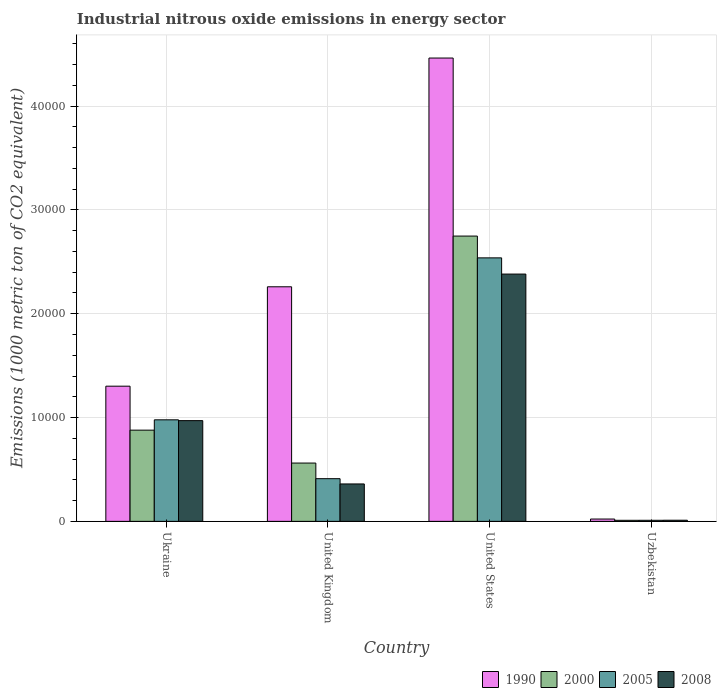How many groups of bars are there?
Provide a succinct answer. 4. Are the number of bars on each tick of the X-axis equal?
Offer a very short reply. Yes. How many bars are there on the 2nd tick from the left?
Make the answer very short. 4. How many bars are there on the 2nd tick from the right?
Offer a terse response. 4. What is the label of the 2nd group of bars from the left?
Your response must be concise. United Kingdom. In how many cases, is the number of bars for a given country not equal to the number of legend labels?
Your response must be concise. 0. What is the amount of industrial nitrous oxide emitted in 2005 in United Kingdom?
Your response must be concise. 4111.2. Across all countries, what is the maximum amount of industrial nitrous oxide emitted in 2005?
Give a very brief answer. 2.54e+04. Across all countries, what is the minimum amount of industrial nitrous oxide emitted in 2000?
Offer a very short reply. 101.6. In which country was the amount of industrial nitrous oxide emitted in 1990 minimum?
Your answer should be compact. Uzbekistan. What is the total amount of industrial nitrous oxide emitted in 2000 in the graph?
Offer a very short reply. 4.20e+04. What is the difference between the amount of industrial nitrous oxide emitted in 1990 in United Kingdom and that in United States?
Your answer should be very brief. -2.20e+04. What is the difference between the amount of industrial nitrous oxide emitted in 2008 in United States and the amount of industrial nitrous oxide emitted in 1990 in United Kingdom?
Offer a very short reply. 1224.8. What is the average amount of industrial nitrous oxide emitted in 2008 per country?
Provide a succinct answer. 9308.4. What is the difference between the amount of industrial nitrous oxide emitted of/in 1990 and amount of industrial nitrous oxide emitted of/in 2000 in United States?
Your response must be concise. 1.71e+04. In how many countries, is the amount of industrial nitrous oxide emitted in 1990 greater than 12000 1000 metric ton?
Your answer should be compact. 3. What is the ratio of the amount of industrial nitrous oxide emitted in 2000 in United Kingdom to that in United States?
Give a very brief answer. 0.2. Is the difference between the amount of industrial nitrous oxide emitted in 1990 in United States and Uzbekistan greater than the difference between the amount of industrial nitrous oxide emitted in 2000 in United States and Uzbekistan?
Provide a succinct answer. Yes. What is the difference between the highest and the second highest amount of industrial nitrous oxide emitted in 2008?
Ensure brevity in your answer.  2.02e+04. What is the difference between the highest and the lowest amount of industrial nitrous oxide emitted in 2005?
Make the answer very short. 2.53e+04. In how many countries, is the amount of industrial nitrous oxide emitted in 1990 greater than the average amount of industrial nitrous oxide emitted in 1990 taken over all countries?
Offer a very short reply. 2. Is it the case that in every country, the sum of the amount of industrial nitrous oxide emitted in 2005 and amount of industrial nitrous oxide emitted in 2008 is greater than the sum of amount of industrial nitrous oxide emitted in 1990 and amount of industrial nitrous oxide emitted in 2000?
Ensure brevity in your answer.  No. What does the 2nd bar from the left in Uzbekistan represents?
Give a very brief answer. 2000. What does the 2nd bar from the right in Ukraine represents?
Ensure brevity in your answer.  2005. How many bars are there?
Your response must be concise. 16. Are all the bars in the graph horizontal?
Ensure brevity in your answer.  No. How many countries are there in the graph?
Offer a very short reply. 4. Where does the legend appear in the graph?
Your answer should be compact. Bottom right. How are the legend labels stacked?
Make the answer very short. Horizontal. What is the title of the graph?
Provide a short and direct response. Industrial nitrous oxide emissions in energy sector. Does "1976" appear as one of the legend labels in the graph?
Offer a terse response. No. What is the label or title of the Y-axis?
Ensure brevity in your answer.  Emissions (1000 metric ton of CO2 equivalent). What is the Emissions (1000 metric ton of CO2 equivalent) in 1990 in Ukraine?
Your response must be concise. 1.30e+04. What is the Emissions (1000 metric ton of CO2 equivalent) of 2000 in Ukraine?
Your answer should be compact. 8784.8. What is the Emissions (1000 metric ton of CO2 equivalent) of 2005 in Ukraine?
Your answer should be very brief. 9779.9. What is the Emissions (1000 metric ton of CO2 equivalent) in 2008 in Ukraine?
Your answer should be very brief. 9701.8. What is the Emissions (1000 metric ton of CO2 equivalent) in 1990 in United Kingdom?
Your response must be concise. 2.26e+04. What is the Emissions (1000 metric ton of CO2 equivalent) in 2000 in United Kingdom?
Offer a very short reply. 5616. What is the Emissions (1000 metric ton of CO2 equivalent) of 2005 in United Kingdom?
Make the answer very short. 4111.2. What is the Emissions (1000 metric ton of CO2 equivalent) in 2008 in United Kingdom?
Your answer should be very brief. 3604.6. What is the Emissions (1000 metric ton of CO2 equivalent) in 1990 in United States?
Give a very brief answer. 4.46e+04. What is the Emissions (1000 metric ton of CO2 equivalent) of 2000 in United States?
Your response must be concise. 2.75e+04. What is the Emissions (1000 metric ton of CO2 equivalent) of 2005 in United States?
Your answer should be very brief. 2.54e+04. What is the Emissions (1000 metric ton of CO2 equivalent) of 2008 in United States?
Your response must be concise. 2.38e+04. What is the Emissions (1000 metric ton of CO2 equivalent) in 1990 in Uzbekistan?
Your answer should be compact. 223.2. What is the Emissions (1000 metric ton of CO2 equivalent) in 2000 in Uzbekistan?
Give a very brief answer. 101.6. What is the Emissions (1000 metric ton of CO2 equivalent) of 2005 in Uzbekistan?
Offer a very short reply. 103.2. What is the Emissions (1000 metric ton of CO2 equivalent) of 2008 in Uzbekistan?
Your answer should be very brief. 109.4. Across all countries, what is the maximum Emissions (1000 metric ton of CO2 equivalent) in 1990?
Your answer should be very brief. 4.46e+04. Across all countries, what is the maximum Emissions (1000 metric ton of CO2 equivalent) in 2000?
Offer a very short reply. 2.75e+04. Across all countries, what is the maximum Emissions (1000 metric ton of CO2 equivalent) in 2005?
Your answer should be compact. 2.54e+04. Across all countries, what is the maximum Emissions (1000 metric ton of CO2 equivalent) of 2008?
Ensure brevity in your answer.  2.38e+04. Across all countries, what is the minimum Emissions (1000 metric ton of CO2 equivalent) of 1990?
Offer a terse response. 223.2. Across all countries, what is the minimum Emissions (1000 metric ton of CO2 equivalent) of 2000?
Give a very brief answer. 101.6. Across all countries, what is the minimum Emissions (1000 metric ton of CO2 equivalent) in 2005?
Offer a terse response. 103.2. Across all countries, what is the minimum Emissions (1000 metric ton of CO2 equivalent) in 2008?
Your response must be concise. 109.4. What is the total Emissions (1000 metric ton of CO2 equivalent) of 1990 in the graph?
Give a very brief answer. 8.05e+04. What is the total Emissions (1000 metric ton of CO2 equivalent) in 2000 in the graph?
Offer a very short reply. 4.20e+04. What is the total Emissions (1000 metric ton of CO2 equivalent) of 2005 in the graph?
Offer a terse response. 3.94e+04. What is the total Emissions (1000 metric ton of CO2 equivalent) of 2008 in the graph?
Keep it short and to the point. 3.72e+04. What is the difference between the Emissions (1000 metric ton of CO2 equivalent) in 1990 in Ukraine and that in United Kingdom?
Keep it short and to the point. -9573. What is the difference between the Emissions (1000 metric ton of CO2 equivalent) in 2000 in Ukraine and that in United Kingdom?
Ensure brevity in your answer.  3168.8. What is the difference between the Emissions (1000 metric ton of CO2 equivalent) in 2005 in Ukraine and that in United Kingdom?
Your answer should be compact. 5668.7. What is the difference between the Emissions (1000 metric ton of CO2 equivalent) in 2008 in Ukraine and that in United Kingdom?
Make the answer very short. 6097.2. What is the difference between the Emissions (1000 metric ton of CO2 equivalent) in 1990 in Ukraine and that in United States?
Make the answer very short. -3.16e+04. What is the difference between the Emissions (1000 metric ton of CO2 equivalent) of 2000 in Ukraine and that in United States?
Ensure brevity in your answer.  -1.87e+04. What is the difference between the Emissions (1000 metric ton of CO2 equivalent) of 2005 in Ukraine and that in United States?
Offer a terse response. -1.56e+04. What is the difference between the Emissions (1000 metric ton of CO2 equivalent) of 2008 in Ukraine and that in United States?
Make the answer very short. -1.41e+04. What is the difference between the Emissions (1000 metric ton of CO2 equivalent) in 1990 in Ukraine and that in Uzbekistan?
Offer a very short reply. 1.28e+04. What is the difference between the Emissions (1000 metric ton of CO2 equivalent) of 2000 in Ukraine and that in Uzbekistan?
Ensure brevity in your answer.  8683.2. What is the difference between the Emissions (1000 metric ton of CO2 equivalent) in 2005 in Ukraine and that in Uzbekistan?
Make the answer very short. 9676.7. What is the difference between the Emissions (1000 metric ton of CO2 equivalent) of 2008 in Ukraine and that in Uzbekistan?
Your response must be concise. 9592.4. What is the difference between the Emissions (1000 metric ton of CO2 equivalent) of 1990 in United Kingdom and that in United States?
Ensure brevity in your answer.  -2.20e+04. What is the difference between the Emissions (1000 metric ton of CO2 equivalent) of 2000 in United Kingdom and that in United States?
Provide a succinct answer. -2.19e+04. What is the difference between the Emissions (1000 metric ton of CO2 equivalent) of 2005 in United Kingdom and that in United States?
Your answer should be compact. -2.13e+04. What is the difference between the Emissions (1000 metric ton of CO2 equivalent) in 2008 in United Kingdom and that in United States?
Provide a succinct answer. -2.02e+04. What is the difference between the Emissions (1000 metric ton of CO2 equivalent) in 1990 in United Kingdom and that in Uzbekistan?
Make the answer very short. 2.24e+04. What is the difference between the Emissions (1000 metric ton of CO2 equivalent) in 2000 in United Kingdom and that in Uzbekistan?
Give a very brief answer. 5514.4. What is the difference between the Emissions (1000 metric ton of CO2 equivalent) of 2005 in United Kingdom and that in Uzbekistan?
Your response must be concise. 4008. What is the difference between the Emissions (1000 metric ton of CO2 equivalent) of 2008 in United Kingdom and that in Uzbekistan?
Offer a terse response. 3495.2. What is the difference between the Emissions (1000 metric ton of CO2 equivalent) in 1990 in United States and that in Uzbekistan?
Keep it short and to the point. 4.44e+04. What is the difference between the Emissions (1000 metric ton of CO2 equivalent) of 2000 in United States and that in Uzbekistan?
Your answer should be very brief. 2.74e+04. What is the difference between the Emissions (1000 metric ton of CO2 equivalent) of 2005 in United States and that in Uzbekistan?
Your response must be concise. 2.53e+04. What is the difference between the Emissions (1000 metric ton of CO2 equivalent) in 2008 in United States and that in Uzbekistan?
Keep it short and to the point. 2.37e+04. What is the difference between the Emissions (1000 metric ton of CO2 equivalent) of 1990 in Ukraine and the Emissions (1000 metric ton of CO2 equivalent) of 2000 in United Kingdom?
Make the answer very short. 7404. What is the difference between the Emissions (1000 metric ton of CO2 equivalent) in 1990 in Ukraine and the Emissions (1000 metric ton of CO2 equivalent) in 2005 in United Kingdom?
Your response must be concise. 8908.8. What is the difference between the Emissions (1000 metric ton of CO2 equivalent) in 1990 in Ukraine and the Emissions (1000 metric ton of CO2 equivalent) in 2008 in United Kingdom?
Keep it short and to the point. 9415.4. What is the difference between the Emissions (1000 metric ton of CO2 equivalent) in 2000 in Ukraine and the Emissions (1000 metric ton of CO2 equivalent) in 2005 in United Kingdom?
Offer a very short reply. 4673.6. What is the difference between the Emissions (1000 metric ton of CO2 equivalent) in 2000 in Ukraine and the Emissions (1000 metric ton of CO2 equivalent) in 2008 in United Kingdom?
Provide a short and direct response. 5180.2. What is the difference between the Emissions (1000 metric ton of CO2 equivalent) in 2005 in Ukraine and the Emissions (1000 metric ton of CO2 equivalent) in 2008 in United Kingdom?
Give a very brief answer. 6175.3. What is the difference between the Emissions (1000 metric ton of CO2 equivalent) in 1990 in Ukraine and the Emissions (1000 metric ton of CO2 equivalent) in 2000 in United States?
Give a very brief answer. -1.45e+04. What is the difference between the Emissions (1000 metric ton of CO2 equivalent) in 1990 in Ukraine and the Emissions (1000 metric ton of CO2 equivalent) in 2005 in United States?
Provide a succinct answer. -1.24e+04. What is the difference between the Emissions (1000 metric ton of CO2 equivalent) of 1990 in Ukraine and the Emissions (1000 metric ton of CO2 equivalent) of 2008 in United States?
Make the answer very short. -1.08e+04. What is the difference between the Emissions (1000 metric ton of CO2 equivalent) of 2000 in Ukraine and the Emissions (1000 metric ton of CO2 equivalent) of 2005 in United States?
Offer a very short reply. -1.66e+04. What is the difference between the Emissions (1000 metric ton of CO2 equivalent) of 2000 in Ukraine and the Emissions (1000 metric ton of CO2 equivalent) of 2008 in United States?
Your response must be concise. -1.50e+04. What is the difference between the Emissions (1000 metric ton of CO2 equivalent) in 2005 in Ukraine and the Emissions (1000 metric ton of CO2 equivalent) in 2008 in United States?
Provide a succinct answer. -1.40e+04. What is the difference between the Emissions (1000 metric ton of CO2 equivalent) of 1990 in Ukraine and the Emissions (1000 metric ton of CO2 equivalent) of 2000 in Uzbekistan?
Provide a short and direct response. 1.29e+04. What is the difference between the Emissions (1000 metric ton of CO2 equivalent) of 1990 in Ukraine and the Emissions (1000 metric ton of CO2 equivalent) of 2005 in Uzbekistan?
Your answer should be compact. 1.29e+04. What is the difference between the Emissions (1000 metric ton of CO2 equivalent) in 1990 in Ukraine and the Emissions (1000 metric ton of CO2 equivalent) in 2008 in Uzbekistan?
Your answer should be very brief. 1.29e+04. What is the difference between the Emissions (1000 metric ton of CO2 equivalent) in 2000 in Ukraine and the Emissions (1000 metric ton of CO2 equivalent) in 2005 in Uzbekistan?
Your answer should be compact. 8681.6. What is the difference between the Emissions (1000 metric ton of CO2 equivalent) of 2000 in Ukraine and the Emissions (1000 metric ton of CO2 equivalent) of 2008 in Uzbekistan?
Your answer should be very brief. 8675.4. What is the difference between the Emissions (1000 metric ton of CO2 equivalent) of 2005 in Ukraine and the Emissions (1000 metric ton of CO2 equivalent) of 2008 in Uzbekistan?
Provide a succinct answer. 9670.5. What is the difference between the Emissions (1000 metric ton of CO2 equivalent) in 1990 in United Kingdom and the Emissions (1000 metric ton of CO2 equivalent) in 2000 in United States?
Your answer should be very brief. -4884.9. What is the difference between the Emissions (1000 metric ton of CO2 equivalent) of 1990 in United Kingdom and the Emissions (1000 metric ton of CO2 equivalent) of 2005 in United States?
Make the answer very short. -2785.7. What is the difference between the Emissions (1000 metric ton of CO2 equivalent) in 1990 in United Kingdom and the Emissions (1000 metric ton of CO2 equivalent) in 2008 in United States?
Your answer should be compact. -1224.8. What is the difference between the Emissions (1000 metric ton of CO2 equivalent) in 2000 in United Kingdom and the Emissions (1000 metric ton of CO2 equivalent) in 2005 in United States?
Offer a very short reply. -1.98e+04. What is the difference between the Emissions (1000 metric ton of CO2 equivalent) in 2000 in United Kingdom and the Emissions (1000 metric ton of CO2 equivalent) in 2008 in United States?
Offer a terse response. -1.82e+04. What is the difference between the Emissions (1000 metric ton of CO2 equivalent) in 2005 in United Kingdom and the Emissions (1000 metric ton of CO2 equivalent) in 2008 in United States?
Your answer should be compact. -1.97e+04. What is the difference between the Emissions (1000 metric ton of CO2 equivalent) in 1990 in United Kingdom and the Emissions (1000 metric ton of CO2 equivalent) in 2000 in Uzbekistan?
Provide a succinct answer. 2.25e+04. What is the difference between the Emissions (1000 metric ton of CO2 equivalent) in 1990 in United Kingdom and the Emissions (1000 metric ton of CO2 equivalent) in 2005 in Uzbekistan?
Ensure brevity in your answer.  2.25e+04. What is the difference between the Emissions (1000 metric ton of CO2 equivalent) in 1990 in United Kingdom and the Emissions (1000 metric ton of CO2 equivalent) in 2008 in Uzbekistan?
Offer a very short reply. 2.25e+04. What is the difference between the Emissions (1000 metric ton of CO2 equivalent) in 2000 in United Kingdom and the Emissions (1000 metric ton of CO2 equivalent) in 2005 in Uzbekistan?
Your answer should be compact. 5512.8. What is the difference between the Emissions (1000 metric ton of CO2 equivalent) in 2000 in United Kingdom and the Emissions (1000 metric ton of CO2 equivalent) in 2008 in Uzbekistan?
Keep it short and to the point. 5506.6. What is the difference between the Emissions (1000 metric ton of CO2 equivalent) of 2005 in United Kingdom and the Emissions (1000 metric ton of CO2 equivalent) of 2008 in Uzbekistan?
Provide a short and direct response. 4001.8. What is the difference between the Emissions (1000 metric ton of CO2 equivalent) of 1990 in United States and the Emissions (1000 metric ton of CO2 equivalent) of 2000 in Uzbekistan?
Offer a very short reply. 4.45e+04. What is the difference between the Emissions (1000 metric ton of CO2 equivalent) of 1990 in United States and the Emissions (1000 metric ton of CO2 equivalent) of 2005 in Uzbekistan?
Offer a terse response. 4.45e+04. What is the difference between the Emissions (1000 metric ton of CO2 equivalent) in 1990 in United States and the Emissions (1000 metric ton of CO2 equivalent) in 2008 in Uzbekistan?
Provide a short and direct response. 4.45e+04. What is the difference between the Emissions (1000 metric ton of CO2 equivalent) in 2000 in United States and the Emissions (1000 metric ton of CO2 equivalent) in 2005 in Uzbekistan?
Your answer should be very brief. 2.74e+04. What is the difference between the Emissions (1000 metric ton of CO2 equivalent) in 2000 in United States and the Emissions (1000 metric ton of CO2 equivalent) in 2008 in Uzbekistan?
Keep it short and to the point. 2.74e+04. What is the difference between the Emissions (1000 metric ton of CO2 equivalent) in 2005 in United States and the Emissions (1000 metric ton of CO2 equivalent) in 2008 in Uzbekistan?
Keep it short and to the point. 2.53e+04. What is the average Emissions (1000 metric ton of CO2 equivalent) in 1990 per country?
Keep it short and to the point. 2.01e+04. What is the average Emissions (1000 metric ton of CO2 equivalent) in 2000 per country?
Ensure brevity in your answer.  1.05e+04. What is the average Emissions (1000 metric ton of CO2 equivalent) of 2005 per country?
Offer a very short reply. 9843.25. What is the average Emissions (1000 metric ton of CO2 equivalent) in 2008 per country?
Offer a very short reply. 9308.4. What is the difference between the Emissions (1000 metric ton of CO2 equivalent) in 1990 and Emissions (1000 metric ton of CO2 equivalent) in 2000 in Ukraine?
Your response must be concise. 4235.2. What is the difference between the Emissions (1000 metric ton of CO2 equivalent) in 1990 and Emissions (1000 metric ton of CO2 equivalent) in 2005 in Ukraine?
Offer a very short reply. 3240.1. What is the difference between the Emissions (1000 metric ton of CO2 equivalent) of 1990 and Emissions (1000 metric ton of CO2 equivalent) of 2008 in Ukraine?
Offer a very short reply. 3318.2. What is the difference between the Emissions (1000 metric ton of CO2 equivalent) in 2000 and Emissions (1000 metric ton of CO2 equivalent) in 2005 in Ukraine?
Give a very brief answer. -995.1. What is the difference between the Emissions (1000 metric ton of CO2 equivalent) of 2000 and Emissions (1000 metric ton of CO2 equivalent) of 2008 in Ukraine?
Keep it short and to the point. -917. What is the difference between the Emissions (1000 metric ton of CO2 equivalent) in 2005 and Emissions (1000 metric ton of CO2 equivalent) in 2008 in Ukraine?
Offer a terse response. 78.1. What is the difference between the Emissions (1000 metric ton of CO2 equivalent) of 1990 and Emissions (1000 metric ton of CO2 equivalent) of 2000 in United Kingdom?
Your answer should be compact. 1.70e+04. What is the difference between the Emissions (1000 metric ton of CO2 equivalent) in 1990 and Emissions (1000 metric ton of CO2 equivalent) in 2005 in United Kingdom?
Provide a succinct answer. 1.85e+04. What is the difference between the Emissions (1000 metric ton of CO2 equivalent) of 1990 and Emissions (1000 metric ton of CO2 equivalent) of 2008 in United Kingdom?
Your response must be concise. 1.90e+04. What is the difference between the Emissions (1000 metric ton of CO2 equivalent) of 2000 and Emissions (1000 metric ton of CO2 equivalent) of 2005 in United Kingdom?
Give a very brief answer. 1504.8. What is the difference between the Emissions (1000 metric ton of CO2 equivalent) of 2000 and Emissions (1000 metric ton of CO2 equivalent) of 2008 in United Kingdom?
Ensure brevity in your answer.  2011.4. What is the difference between the Emissions (1000 metric ton of CO2 equivalent) in 2005 and Emissions (1000 metric ton of CO2 equivalent) in 2008 in United Kingdom?
Give a very brief answer. 506.6. What is the difference between the Emissions (1000 metric ton of CO2 equivalent) in 1990 and Emissions (1000 metric ton of CO2 equivalent) in 2000 in United States?
Provide a short and direct response. 1.71e+04. What is the difference between the Emissions (1000 metric ton of CO2 equivalent) in 1990 and Emissions (1000 metric ton of CO2 equivalent) in 2005 in United States?
Provide a succinct answer. 1.92e+04. What is the difference between the Emissions (1000 metric ton of CO2 equivalent) in 1990 and Emissions (1000 metric ton of CO2 equivalent) in 2008 in United States?
Ensure brevity in your answer.  2.08e+04. What is the difference between the Emissions (1000 metric ton of CO2 equivalent) of 2000 and Emissions (1000 metric ton of CO2 equivalent) of 2005 in United States?
Your answer should be very brief. 2099.2. What is the difference between the Emissions (1000 metric ton of CO2 equivalent) in 2000 and Emissions (1000 metric ton of CO2 equivalent) in 2008 in United States?
Offer a terse response. 3660.1. What is the difference between the Emissions (1000 metric ton of CO2 equivalent) of 2005 and Emissions (1000 metric ton of CO2 equivalent) of 2008 in United States?
Provide a succinct answer. 1560.9. What is the difference between the Emissions (1000 metric ton of CO2 equivalent) in 1990 and Emissions (1000 metric ton of CO2 equivalent) in 2000 in Uzbekistan?
Offer a very short reply. 121.6. What is the difference between the Emissions (1000 metric ton of CO2 equivalent) in 1990 and Emissions (1000 metric ton of CO2 equivalent) in 2005 in Uzbekistan?
Your answer should be very brief. 120. What is the difference between the Emissions (1000 metric ton of CO2 equivalent) of 1990 and Emissions (1000 metric ton of CO2 equivalent) of 2008 in Uzbekistan?
Offer a very short reply. 113.8. What is the difference between the Emissions (1000 metric ton of CO2 equivalent) in 2000 and Emissions (1000 metric ton of CO2 equivalent) in 2005 in Uzbekistan?
Ensure brevity in your answer.  -1.6. What is the difference between the Emissions (1000 metric ton of CO2 equivalent) in 2005 and Emissions (1000 metric ton of CO2 equivalent) in 2008 in Uzbekistan?
Provide a succinct answer. -6.2. What is the ratio of the Emissions (1000 metric ton of CO2 equivalent) in 1990 in Ukraine to that in United Kingdom?
Offer a very short reply. 0.58. What is the ratio of the Emissions (1000 metric ton of CO2 equivalent) of 2000 in Ukraine to that in United Kingdom?
Offer a very short reply. 1.56. What is the ratio of the Emissions (1000 metric ton of CO2 equivalent) of 2005 in Ukraine to that in United Kingdom?
Offer a terse response. 2.38. What is the ratio of the Emissions (1000 metric ton of CO2 equivalent) of 2008 in Ukraine to that in United Kingdom?
Offer a terse response. 2.69. What is the ratio of the Emissions (1000 metric ton of CO2 equivalent) in 1990 in Ukraine to that in United States?
Your answer should be very brief. 0.29. What is the ratio of the Emissions (1000 metric ton of CO2 equivalent) of 2000 in Ukraine to that in United States?
Offer a very short reply. 0.32. What is the ratio of the Emissions (1000 metric ton of CO2 equivalent) in 2005 in Ukraine to that in United States?
Offer a very short reply. 0.39. What is the ratio of the Emissions (1000 metric ton of CO2 equivalent) of 2008 in Ukraine to that in United States?
Give a very brief answer. 0.41. What is the ratio of the Emissions (1000 metric ton of CO2 equivalent) in 1990 in Ukraine to that in Uzbekistan?
Your response must be concise. 58.33. What is the ratio of the Emissions (1000 metric ton of CO2 equivalent) in 2000 in Ukraine to that in Uzbekistan?
Your response must be concise. 86.46. What is the ratio of the Emissions (1000 metric ton of CO2 equivalent) of 2005 in Ukraine to that in Uzbekistan?
Make the answer very short. 94.77. What is the ratio of the Emissions (1000 metric ton of CO2 equivalent) in 2008 in Ukraine to that in Uzbekistan?
Provide a succinct answer. 88.68. What is the ratio of the Emissions (1000 metric ton of CO2 equivalent) in 1990 in United Kingdom to that in United States?
Provide a succinct answer. 0.51. What is the ratio of the Emissions (1000 metric ton of CO2 equivalent) in 2000 in United Kingdom to that in United States?
Offer a terse response. 0.2. What is the ratio of the Emissions (1000 metric ton of CO2 equivalent) of 2005 in United Kingdom to that in United States?
Ensure brevity in your answer.  0.16. What is the ratio of the Emissions (1000 metric ton of CO2 equivalent) in 2008 in United Kingdom to that in United States?
Your answer should be compact. 0.15. What is the ratio of the Emissions (1000 metric ton of CO2 equivalent) in 1990 in United Kingdom to that in Uzbekistan?
Give a very brief answer. 101.22. What is the ratio of the Emissions (1000 metric ton of CO2 equivalent) of 2000 in United Kingdom to that in Uzbekistan?
Provide a short and direct response. 55.28. What is the ratio of the Emissions (1000 metric ton of CO2 equivalent) in 2005 in United Kingdom to that in Uzbekistan?
Ensure brevity in your answer.  39.84. What is the ratio of the Emissions (1000 metric ton of CO2 equivalent) of 2008 in United Kingdom to that in Uzbekistan?
Provide a short and direct response. 32.95. What is the ratio of the Emissions (1000 metric ton of CO2 equivalent) in 1990 in United States to that in Uzbekistan?
Offer a terse response. 199.93. What is the ratio of the Emissions (1000 metric ton of CO2 equivalent) in 2000 in United States to that in Uzbekistan?
Provide a short and direct response. 270.45. What is the ratio of the Emissions (1000 metric ton of CO2 equivalent) of 2005 in United States to that in Uzbekistan?
Your response must be concise. 245.92. What is the ratio of the Emissions (1000 metric ton of CO2 equivalent) in 2008 in United States to that in Uzbekistan?
Ensure brevity in your answer.  217.71. What is the difference between the highest and the second highest Emissions (1000 metric ton of CO2 equivalent) of 1990?
Your answer should be very brief. 2.20e+04. What is the difference between the highest and the second highest Emissions (1000 metric ton of CO2 equivalent) of 2000?
Offer a terse response. 1.87e+04. What is the difference between the highest and the second highest Emissions (1000 metric ton of CO2 equivalent) of 2005?
Your response must be concise. 1.56e+04. What is the difference between the highest and the second highest Emissions (1000 metric ton of CO2 equivalent) of 2008?
Keep it short and to the point. 1.41e+04. What is the difference between the highest and the lowest Emissions (1000 metric ton of CO2 equivalent) of 1990?
Provide a succinct answer. 4.44e+04. What is the difference between the highest and the lowest Emissions (1000 metric ton of CO2 equivalent) in 2000?
Give a very brief answer. 2.74e+04. What is the difference between the highest and the lowest Emissions (1000 metric ton of CO2 equivalent) in 2005?
Your answer should be very brief. 2.53e+04. What is the difference between the highest and the lowest Emissions (1000 metric ton of CO2 equivalent) in 2008?
Your response must be concise. 2.37e+04. 